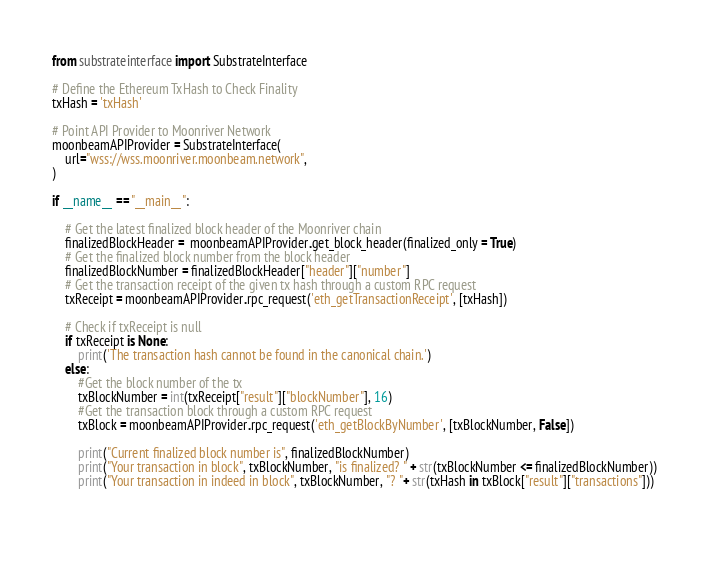<code> <loc_0><loc_0><loc_500><loc_500><_Python_>from substrateinterface import SubstrateInterface

# Define the Ethereum TxHash to Check Finality
txHash = 'txHash'

# Point API Provider to Moonriver Network
moonbeamAPIProvider = SubstrateInterface(
    url="wss://wss.moonriver.moonbeam.network",
)

if __name__ == "__main__":

    # Get the latest finalized block header of the Moonriver chain
    finalizedBlockHeader =  moonbeamAPIProvider.get_block_header(finalized_only = True)
    # Get the finalized block number from the block header
    finalizedBlockNumber = finalizedBlockHeader["header"]["number"]
    # Get the transaction receipt of the given tx hash through a custom RPC request
    txReceipt = moonbeamAPIProvider.rpc_request('eth_getTransactionReceipt', [txHash])

    # Check if txReceipt is null 
    if txReceipt is None:
        print('The transaction hash cannot be found in the canonical chain.')
    else:
        #Get the block number of the tx
        txBlockNumber = int(txReceipt["result"]["blockNumber"], 16)
        #Get the transaction block through a custom RPC request
        txBlock = moonbeamAPIProvider.rpc_request('eth_getBlockByNumber', [txBlockNumber, False])
        
        print("Current finalized block number is", finalizedBlockNumber)
        print("Your transaction in block", txBlockNumber, "is finalized? " + str(txBlockNumber <= finalizedBlockNumber))
        print("Your transaction in indeed in block", txBlockNumber, "? "+ str(txHash in txBlock["result"]["transactions"]))

    
</code> 